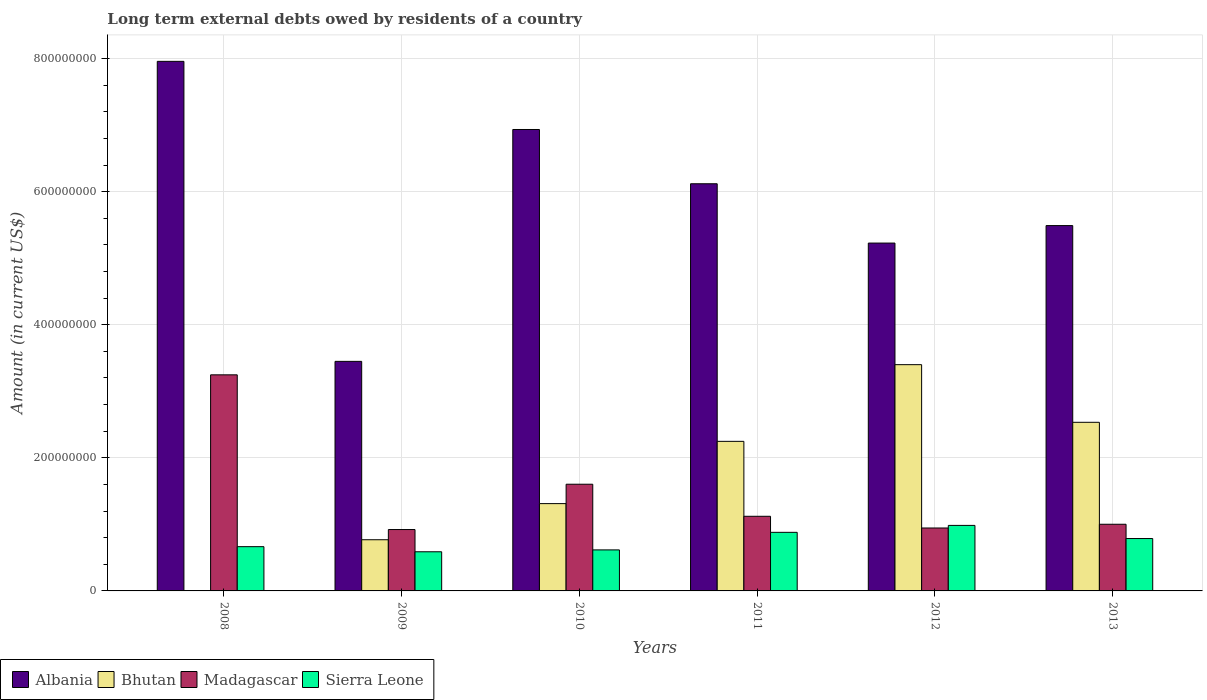How many groups of bars are there?
Keep it short and to the point. 6. Are the number of bars on each tick of the X-axis equal?
Make the answer very short. No. What is the label of the 5th group of bars from the left?
Provide a short and direct response. 2012. In how many cases, is the number of bars for a given year not equal to the number of legend labels?
Your answer should be compact. 1. What is the amount of long-term external debts owed by residents in Madagascar in 2008?
Ensure brevity in your answer.  3.25e+08. Across all years, what is the maximum amount of long-term external debts owed by residents in Albania?
Your answer should be compact. 7.96e+08. Across all years, what is the minimum amount of long-term external debts owed by residents in Bhutan?
Offer a very short reply. 0. In which year was the amount of long-term external debts owed by residents in Albania maximum?
Provide a succinct answer. 2008. What is the total amount of long-term external debts owed by residents in Albania in the graph?
Provide a succinct answer. 3.52e+09. What is the difference between the amount of long-term external debts owed by residents in Albania in 2012 and that in 2013?
Keep it short and to the point. -2.63e+07. What is the difference between the amount of long-term external debts owed by residents in Madagascar in 2011 and the amount of long-term external debts owed by residents in Bhutan in 2012?
Provide a succinct answer. -2.28e+08. What is the average amount of long-term external debts owed by residents in Albania per year?
Make the answer very short. 5.86e+08. In the year 2010, what is the difference between the amount of long-term external debts owed by residents in Albania and amount of long-term external debts owed by residents in Madagascar?
Offer a very short reply. 5.33e+08. What is the ratio of the amount of long-term external debts owed by residents in Madagascar in 2008 to that in 2010?
Your answer should be very brief. 2.03. Is the difference between the amount of long-term external debts owed by residents in Albania in 2008 and 2011 greater than the difference between the amount of long-term external debts owed by residents in Madagascar in 2008 and 2011?
Provide a short and direct response. No. What is the difference between the highest and the second highest amount of long-term external debts owed by residents in Sierra Leone?
Keep it short and to the point. 1.04e+07. What is the difference between the highest and the lowest amount of long-term external debts owed by residents in Madagascar?
Provide a succinct answer. 2.33e+08. In how many years, is the amount of long-term external debts owed by residents in Madagascar greater than the average amount of long-term external debts owed by residents in Madagascar taken over all years?
Provide a succinct answer. 2. How many bars are there?
Make the answer very short. 23. Are all the bars in the graph horizontal?
Provide a short and direct response. No. Are the values on the major ticks of Y-axis written in scientific E-notation?
Your response must be concise. No. Where does the legend appear in the graph?
Provide a succinct answer. Bottom left. How are the legend labels stacked?
Your answer should be very brief. Horizontal. What is the title of the graph?
Ensure brevity in your answer.  Long term external debts owed by residents of a country. What is the label or title of the X-axis?
Provide a succinct answer. Years. What is the Amount (in current US$) in Albania in 2008?
Ensure brevity in your answer.  7.96e+08. What is the Amount (in current US$) in Madagascar in 2008?
Your answer should be very brief. 3.25e+08. What is the Amount (in current US$) in Sierra Leone in 2008?
Keep it short and to the point. 6.65e+07. What is the Amount (in current US$) in Albania in 2009?
Provide a succinct answer. 3.45e+08. What is the Amount (in current US$) in Bhutan in 2009?
Keep it short and to the point. 7.69e+07. What is the Amount (in current US$) in Madagascar in 2009?
Make the answer very short. 9.23e+07. What is the Amount (in current US$) of Sierra Leone in 2009?
Your answer should be very brief. 5.88e+07. What is the Amount (in current US$) in Albania in 2010?
Keep it short and to the point. 6.93e+08. What is the Amount (in current US$) of Bhutan in 2010?
Your answer should be compact. 1.31e+08. What is the Amount (in current US$) in Madagascar in 2010?
Your answer should be compact. 1.60e+08. What is the Amount (in current US$) in Sierra Leone in 2010?
Your response must be concise. 6.16e+07. What is the Amount (in current US$) in Albania in 2011?
Keep it short and to the point. 6.12e+08. What is the Amount (in current US$) of Bhutan in 2011?
Your answer should be compact. 2.25e+08. What is the Amount (in current US$) of Madagascar in 2011?
Provide a short and direct response. 1.12e+08. What is the Amount (in current US$) of Sierra Leone in 2011?
Your answer should be very brief. 8.81e+07. What is the Amount (in current US$) of Albania in 2012?
Offer a terse response. 5.23e+08. What is the Amount (in current US$) in Bhutan in 2012?
Offer a very short reply. 3.40e+08. What is the Amount (in current US$) in Madagascar in 2012?
Your answer should be very brief. 9.46e+07. What is the Amount (in current US$) of Sierra Leone in 2012?
Your answer should be very brief. 9.85e+07. What is the Amount (in current US$) in Albania in 2013?
Give a very brief answer. 5.49e+08. What is the Amount (in current US$) in Bhutan in 2013?
Your answer should be very brief. 2.53e+08. What is the Amount (in current US$) of Madagascar in 2013?
Give a very brief answer. 1.00e+08. What is the Amount (in current US$) of Sierra Leone in 2013?
Make the answer very short. 7.87e+07. Across all years, what is the maximum Amount (in current US$) of Albania?
Ensure brevity in your answer.  7.96e+08. Across all years, what is the maximum Amount (in current US$) in Bhutan?
Offer a very short reply. 3.40e+08. Across all years, what is the maximum Amount (in current US$) in Madagascar?
Provide a succinct answer. 3.25e+08. Across all years, what is the maximum Amount (in current US$) in Sierra Leone?
Your answer should be very brief. 9.85e+07. Across all years, what is the minimum Amount (in current US$) in Albania?
Your answer should be very brief. 3.45e+08. Across all years, what is the minimum Amount (in current US$) in Bhutan?
Your response must be concise. 0. Across all years, what is the minimum Amount (in current US$) in Madagascar?
Provide a short and direct response. 9.23e+07. Across all years, what is the minimum Amount (in current US$) in Sierra Leone?
Offer a very short reply. 5.88e+07. What is the total Amount (in current US$) of Albania in the graph?
Give a very brief answer. 3.52e+09. What is the total Amount (in current US$) in Bhutan in the graph?
Your answer should be very brief. 1.03e+09. What is the total Amount (in current US$) in Madagascar in the graph?
Offer a very short reply. 8.84e+08. What is the total Amount (in current US$) in Sierra Leone in the graph?
Your answer should be compact. 4.52e+08. What is the difference between the Amount (in current US$) of Albania in 2008 and that in 2009?
Your answer should be compact. 4.51e+08. What is the difference between the Amount (in current US$) of Madagascar in 2008 and that in 2009?
Ensure brevity in your answer.  2.33e+08. What is the difference between the Amount (in current US$) in Sierra Leone in 2008 and that in 2009?
Provide a short and direct response. 7.70e+06. What is the difference between the Amount (in current US$) in Albania in 2008 and that in 2010?
Ensure brevity in your answer.  1.02e+08. What is the difference between the Amount (in current US$) of Madagascar in 2008 and that in 2010?
Offer a terse response. 1.64e+08. What is the difference between the Amount (in current US$) in Sierra Leone in 2008 and that in 2010?
Offer a terse response. 4.88e+06. What is the difference between the Amount (in current US$) in Albania in 2008 and that in 2011?
Ensure brevity in your answer.  1.84e+08. What is the difference between the Amount (in current US$) in Madagascar in 2008 and that in 2011?
Give a very brief answer. 2.13e+08. What is the difference between the Amount (in current US$) in Sierra Leone in 2008 and that in 2011?
Ensure brevity in your answer.  -2.15e+07. What is the difference between the Amount (in current US$) of Albania in 2008 and that in 2012?
Provide a short and direct response. 2.73e+08. What is the difference between the Amount (in current US$) in Madagascar in 2008 and that in 2012?
Your answer should be very brief. 2.30e+08. What is the difference between the Amount (in current US$) in Sierra Leone in 2008 and that in 2012?
Provide a short and direct response. -3.20e+07. What is the difference between the Amount (in current US$) of Albania in 2008 and that in 2013?
Offer a terse response. 2.47e+08. What is the difference between the Amount (in current US$) in Madagascar in 2008 and that in 2013?
Give a very brief answer. 2.25e+08. What is the difference between the Amount (in current US$) of Sierra Leone in 2008 and that in 2013?
Your response must be concise. -1.22e+07. What is the difference between the Amount (in current US$) in Albania in 2009 and that in 2010?
Offer a terse response. -3.48e+08. What is the difference between the Amount (in current US$) of Bhutan in 2009 and that in 2010?
Give a very brief answer. -5.43e+07. What is the difference between the Amount (in current US$) of Madagascar in 2009 and that in 2010?
Offer a very short reply. -6.81e+07. What is the difference between the Amount (in current US$) of Sierra Leone in 2009 and that in 2010?
Give a very brief answer. -2.82e+06. What is the difference between the Amount (in current US$) of Albania in 2009 and that in 2011?
Provide a short and direct response. -2.67e+08. What is the difference between the Amount (in current US$) of Bhutan in 2009 and that in 2011?
Provide a short and direct response. -1.48e+08. What is the difference between the Amount (in current US$) of Madagascar in 2009 and that in 2011?
Offer a very short reply. -1.99e+07. What is the difference between the Amount (in current US$) in Sierra Leone in 2009 and that in 2011?
Your answer should be very brief. -2.92e+07. What is the difference between the Amount (in current US$) of Albania in 2009 and that in 2012?
Provide a short and direct response. -1.78e+08. What is the difference between the Amount (in current US$) in Bhutan in 2009 and that in 2012?
Your answer should be compact. -2.63e+08. What is the difference between the Amount (in current US$) of Madagascar in 2009 and that in 2012?
Your response must be concise. -2.33e+06. What is the difference between the Amount (in current US$) of Sierra Leone in 2009 and that in 2012?
Your answer should be compact. -3.97e+07. What is the difference between the Amount (in current US$) in Albania in 2009 and that in 2013?
Your answer should be very brief. -2.04e+08. What is the difference between the Amount (in current US$) of Bhutan in 2009 and that in 2013?
Your response must be concise. -1.76e+08. What is the difference between the Amount (in current US$) of Madagascar in 2009 and that in 2013?
Keep it short and to the point. -7.94e+06. What is the difference between the Amount (in current US$) in Sierra Leone in 2009 and that in 2013?
Your response must be concise. -1.99e+07. What is the difference between the Amount (in current US$) in Albania in 2010 and that in 2011?
Provide a short and direct response. 8.15e+07. What is the difference between the Amount (in current US$) of Bhutan in 2010 and that in 2011?
Offer a very short reply. -9.36e+07. What is the difference between the Amount (in current US$) in Madagascar in 2010 and that in 2011?
Provide a short and direct response. 4.82e+07. What is the difference between the Amount (in current US$) of Sierra Leone in 2010 and that in 2011?
Keep it short and to the point. -2.64e+07. What is the difference between the Amount (in current US$) in Albania in 2010 and that in 2012?
Give a very brief answer. 1.71e+08. What is the difference between the Amount (in current US$) of Bhutan in 2010 and that in 2012?
Make the answer very short. -2.09e+08. What is the difference between the Amount (in current US$) of Madagascar in 2010 and that in 2012?
Your response must be concise. 6.58e+07. What is the difference between the Amount (in current US$) of Sierra Leone in 2010 and that in 2012?
Your response must be concise. -3.68e+07. What is the difference between the Amount (in current US$) in Albania in 2010 and that in 2013?
Keep it short and to the point. 1.44e+08. What is the difference between the Amount (in current US$) of Bhutan in 2010 and that in 2013?
Your answer should be compact. -1.22e+08. What is the difference between the Amount (in current US$) in Madagascar in 2010 and that in 2013?
Provide a short and direct response. 6.02e+07. What is the difference between the Amount (in current US$) of Sierra Leone in 2010 and that in 2013?
Your answer should be compact. -1.71e+07. What is the difference between the Amount (in current US$) in Albania in 2011 and that in 2012?
Provide a short and direct response. 8.91e+07. What is the difference between the Amount (in current US$) in Bhutan in 2011 and that in 2012?
Provide a succinct answer. -1.15e+08. What is the difference between the Amount (in current US$) of Madagascar in 2011 and that in 2012?
Ensure brevity in your answer.  1.76e+07. What is the difference between the Amount (in current US$) of Sierra Leone in 2011 and that in 2012?
Your answer should be very brief. -1.04e+07. What is the difference between the Amount (in current US$) in Albania in 2011 and that in 2013?
Offer a very short reply. 6.29e+07. What is the difference between the Amount (in current US$) of Bhutan in 2011 and that in 2013?
Offer a very short reply. -2.86e+07. What is the difference between the Amount (in current US$) of Madagascar in 2011 and that in 2013?
Keep it short and to the point. 1.20e+07. What is the difference between the Amount (in current US$) in Sierra Leone in 2011 and that in 2013?
Your answer should be very brief. 9.32e+06. What is the difference between the Amount (in current US$) in Albania in 2012 and that in 2013?
Provide a short and direct response. -2.63e+07. What is the difference between the Amount (in current US$) in Bhutan in 2012 and that in 2013?
Ensure brevity in your answer.  8.66e+07. What is the difference between the Amount (in current US$) in Madagascar in 2012 and that in 2013?
Make the answer very short. -5.60e+06. What is the difference between the Amount (in current US$) in Sierra Leone in 2012 and that in 2013?
Your answer should be very brief. 1.98e+07. What is the difference between the Amount (in current US$) in Albania in 2008 and the Amount (in current US$) in Bhutan in 2009?
Your answer should be compact. 7.19e+08. What is the difference between the Amount (in current US$) in Albania in 2008 and the Amount (in current US$) in Madagascar in 2009?
Provide a succinct answer. 7.04e+08. What is the difference between the Amount (in current US$) in Albania in 2008 and the Amount (in current US$) in Sierra Leone in 2009?
Keep it short and to the point. 7.37e+08. What is the difference between the Amount (in current US$) in Madagascar in 2008 and the Amount (in current US$) in Sierra Leone in 2009?
Make the answer very short. 2.66e+08. What is the difference between the Amount (in current US$) in Albania in 2008 and the Amount (in current US$) in Bhutan in 2010?
Keep it short and to the point. 6.65e+08. What is the difference between the Amount (in current US$) of Albania in 2008 and the Amount (in current US$) of Madagascar in 2010?
Ensure brevity in your answer.  6.36e+08. What is the difference between the Amount (in current US$) of Albania in 2008 and the Amount (in current US$) of Sierra Leone in 2010?
Keep it short and to the point. 7.34e+08. What is the difference between the Amount (in current US$) in Madagascar in 2008 and the Amount (in current US$) in Sierra Leone in 2010?
Offer a terse response. 2.63e+08. What is the difference between the Amount (in current US$) in Albania in 2008 and the Amount (in current US$) in Bhutan in 2011?
Your response must be concise. 5.71e+08. What is the difference between the Amount (in current US$) of Albania in 2008 and the Amount (in current US$) of Madagascar in 2011?
Offer a very short reply. 6.84e+08. What is the difference between the Amount (in current US$) in Albania in 2008 and the Amount (in current US$) in Sierra Leone in 2011?
Offer a very short reply. 7.08e+08. What is the difference between the Amount (in current US$) of Madagascar in 2008 and the Amount (in current US$) of Sierra Leone in 2011?
Ensure brevity in your answer.  2.37e+08. What is the difference between the Amount (in current US$) of Albania in 2008 and the Amount (in current US$) of Bhutan in 2012?
Provide a short and direct response. 4.56e+08. What is the difference between the Amount (in current US$) in Albania in 2008 and the Amount (in current US$) in Madagascar in 2012?
Give a very brief answer. 7.01e+08. What is the difference between the Amount (in current US$) in Albania in 2008 and the Amount (in current US$) in Sierra Leone in 2012?
Offer a terse response. 6.97e+08. What is the difference between the Amount (in current US$) of Madagascar in 2008 and the Amount (in current US$) of Sierra Leone in 2012?
Keep it short and to the point. 2.26e+08. What is the difference between the Amount (in current US$) in Albania in 2008 and the Amount (in current US$) in Bhutan in 2013?
Provide a succinct answer. 5.42e+08. What is the difference between the Amount (in current US$) of Albania in 2008 and the Amount (in current US$) of Madagascar in 2013?
Keep it short and to the point. 6.96e+08. What is the difference between the Amount (in current US$) in Albania in 2008 and the Amount (in current US$) in Sierra Leone in 2013?
Offer a very short reply. 7.17e+08. What is the difference between the Amount (in current US$) of Madagascar in 2008 and the Amount (in current US$) of Sierra Leone in 2013?
Provide a short and direct response. 2.46e+08. What is the difference between the Amount (in current US$) in Albania in 2009 and the Amount (in current US$) in Bhutan in 2010?
Offer a terse response. 2.14e+08. What is the difference between the Amount (in current US$) in Albania in 2009 and the Amount (in current US$) in Madagascar in 2010?
Offer a very short reply. 1.85e+08. What is the difference between the Amount (in current US$) of Albania in 2009 and the Amount (in current US$) of Sierra Leone in 2010?
Make the answer very short. 2.83e+08. What is the difference between the Amount (in current US$) of Bhutan in 2009 and the Amount (in current US$) of Madagascar in 2010?
Your response must be concise. -8.34e+07. What is the difference between the Amount (in current US$) of Bhutan in 2009 and the Amount (in current US$) of Sierra Leone in 2010?
Make the answer very short. 1.53e+07. What is the difference between the Amount (in current US$) of Madagascar in 2009 and the Amount (in current US$) of Sierra Leone in 2010?
Provide a succinct answer. 3.06e+07. What is the difference between the Amount (in current US$) in Albania in 2009 and the Amount (in current US$) in Bhutan in 2011?
Make the answer very short. 1.20e+08. What is the difference between the Amount (in current US$) of Albania in 2009 and the Amount (in current US$) of Madagascar in 2011?
Make the answer very short. 2.33e+08. What is the difference between the Amount (in current US$) of Albania in 2009 and the Amount (in current US$) of Sierra Leone in 2011?
Offer a very short reply. 2.57e+08. What is the difference between the Amount (in current US$) of Bhutan in 2009 and the Amount (in current US$) of Madagascar in 2011?
Ensure brevity in your answer.  -3.52e+07. What is the difference between the Amount (in current US$) in Bhutan in 2009 and the Amount (in current US$) in Sierra Leone in 2011?
Offer a terse response. -1.11e+07. What is the difference between the Amount (in current US$) in Madagascar in 2009 and the Amount (in current US$) in Sierra Leone in 2011?
Keep it short and to the point. 4.20e+06. What is the difference between the Amount (in current US$) in Albania in 2009 and the Amount (in current US$) in Bhutan in 2012?
Provide a short and direct response. 4.95e+06. What is the difference between the Amount (in current US$) of Albania in 2009 and the Amount (in current US$) of Madagascar in 2012?
Your answer should be compact. 2.50e+08. What is the difference between the Amount (in current US$) of Albania in 2009 and the Amount (in current US$) of Sierra Leone in 2012?
Ensure brevity in your answer.  2.46e+08. What is the difference between the Amount (in current US$) in Bhutan in 2009 and the Amount (in current US$) in Madagascar in 2012?
Provide a short and direct response. -1.77e+07. What is the difference between the Amount (in current US$) in Bhutan in 2009 and the Amount (in current US$) in Sierra Leone in 2012?
Give a very brief answer. -2.16e+07. What is the difference between the Amount (in current US$) of Madagascar in 2009 and the Amount (in current US$) of Sierra Leone in 2012?
Your answer should be very brief. -6.23e+06. What is the difference between the Amount (in current US$) of Albania in 2009 and the Amount (in current US$) of Bhutan in 2013?
Offer a very short reply. 9.16e+07. What is the difference between the Amount (in current US$) of Albania in 2009 and the Amount (in current US$) of Madagascar in 2013?
Provide a succinct answer. 2.45e+08. What is the difference between the Amount (in current US$) of Albania in 2009 and the Amount (in current US$) of Sierra Leone in 2013?
Provide a short and direct response. 2.66e+08. What is the difference between the Amount (in current US$) of Bhutan in 2009 and the Amount (in current US$) of Madagascar in 2013?
Your response must be concise. -2.33e+07. What is the difference between the Amount (in current US$) of Bhutan in 2009 and the Amount (in current US$) of Sierra Leone in 2013?
Ensure brevity in your answer.  -1.80e+06. What is the difference between the Amount (in current US$) in Madagascar in 2009 and the Amount (in current US$) in Sierra Leone in 2013?
Offer a terse response. 1.35e+07. What is the difference between the Amount (in current US$) of Albania in 2010 and the Amount (in current US$) of Bhutan in 2011?
Your response must be concise. 4.69e+08. What is the difference between the Amount (in current US$) in Albania in 2010 and the Amount (in current US$) in Madagascar in 2011?
Make the answer very short. 5.81e+08. What is the difference between the Amount (in current US$) in Albania in 2010 and the Amount (in current US$) in Sierra Leone in 2011?
Provide a succinct answer. 6.05e+08. What is the difference between the Amount (in current US$) in Bhutan in 2010 and the Amount (in current US$) in Madagascar in 2011?
Ensure brevity in your answer.  1.90e+07. What is the difference between the Amount (in current US$) of Bhutan in 2010 and the Amount (in current US$) of Sierra Leone in 2011?
Offer a terse response. 4.32e+07. What is the difference between the Amount (in current US$) in Madagascar in 2010 and the Amount (in current US$) in Sierra Leone in 2011?
Provide a short and direct response. 7.23e+07. What is the difference between the Amount (in current US$) of Albania in 2010 and the Amount (in current US$) of Bhutan in 2012?
Your answer should be compact. 3.53e+08. What is the difference between the Amount (in current US$) of Albania in 2010 and the Amount (in current US$) of Madagascar in 2012?
Offer a terse response. 5.99e+08. What is the difference between the Amount (in current US$) in Albania in 2010 and the Amount (in current US$) in Sierra Leone in 2012?
Offer a terse response. 5.95e+08. What is the difference between the Amount (in current US$) of Bhutan in 2010 and the Amount (in current US$) of Madagascar in 2012?
Your response must be concise. 3.66e+07. What is the difference between the Amount (in current US$) of Bhutan in 2010 and the Amount (in current US$) of Sierra Leone in 2012?
Provide a short and direct response. 3.27e+07. What is the difference between the Amount (in current US$) in Madagascar in 2010 and the Amount (in current US$) in Sierra Leone in 2012?
Your answer should be compact. 6.19e+07. What is the difference between the Amount (in current US$) in Albania in 2010 and the Amount (in current US$) in Bhutan in 2013?
Ensure brevity in your answer.  4.40e+08. What is the difference between the Amount (in current US$) in Albania in 2010 and the Amount (in current US$) in Madagascar in 2013?
Keep it short and to the point. 5.93e+08. What is the difference between the Amount (in current US$) of Albania in 2010 and the Amount (in current US$) of Sierra Leone in 2013?
Give a very brief answer. 6.15e+08. What is the difference between the Amount (in current US$) of Bhutan in 2010 and the Amount (in current US$) of Madagascar in 2013?
Offer a terse response. 3.10e+07. What is the difference between the Amount (in current US$) of Bhutan in 2010 and the Amount (in current US$) of Sierra Leone in 2013?
Offer a very short reply. 5.25e+07. What is the difference between the Amount (in current US$) in Madagascar in 2010 and the Amount (in current US$) in Sierra Leone in 2013?
Give a very brief answer. 8.16e+07. What is the difference between the Amount (in current US$) of Albania in 2011 and the Amount (in current US$) of Bhutan in 2012?
Provide a succinct answer. 2.72e+08. What is the difference between the Amount (in current US$) in Albania in 2011 and the Amount (in current US$) in Madagascar in 2012?
Make the answer very short. 5.17e+08. What is the difference between the Amount (in current US$) in Albania in 2011 and the Amount (in current US$) in Sierra Leone in 2012?
Your answer should be compact. 5.13e+08. What is the difference between the Amount (in current US$) of Bhutan in 2011 and the Amount (in current US$) of Madagascar in 2012?
Provide a short and direct response. 1.30e+08. What is the difference between the Amount (in current US$) in Bhutan in 2011 and the Amount (in current US$) in Sierra Leone in 2012?
Ensure brevity in your answer.  1.26e+08. What is the difference between the Amount (in current US$) of Madagascar in 2011 and the Amount (in current US$) of Sierra Leone in 2012?
Offer a terse response. 1.37e+07. What is the difference between the Amount (in current US$) in Albania in 2011 and the Amount (in current US$) in Bhutan in 2013?
Provide a short and direct response. 3.59e+08. What is the difference between the Amount (in current US$) in Albania in 2011 and the Amount (in current US$) in Madagascar in 2013?
Make the answer very short. 5.12e+08. What is the difference between the Amount (in current US$) of Albania in 2011 and the Amount (in current US$) of Sierra Leone in 2013?
Offer a very short reply. 5.33e+08. What is the difference between the Amount (in current US$) in Bhutan in 2011 and the Amount (in current US$) in Madagascar in 2013?
Provide a succinct answer. 1.25e+08. What is the difference between the Amount (in current US$) in Bhutan in 2011 and the Amount (in current US$) in Sierra Leone in 2013?
Keep it short and to the point. 1.46e+08. What is the difference between the Amount (in current US$) in Madagascar in 2011 and the Amount (in current US$) in Sierra Leone in 2013?
Give a very brief answer. 3.34e+07. What is the difference between the Amount (in current US$) in Albania in 2012 and the Amount (in current US$) in Bhutan in 2013?
Keep it short and to the point. 2.69e+08. What is the difference between the Amount (in current US$) of Albania in 2012 and the Amount (in current US$) of Madagascar in 2013?
Keep it short and to the point. 4.23e+08. What is the difference between the Amount (in current US$) in Albania in 2012 and the Amount (in current US$) in Sierra Leone in 2013?
Keep it short and to the point. 4.44e+08. What is the difference between the Amount (in current US$) of Bhutan in 2012 and the Amount (in current US$) of Madagascar in 2013?
Keep it short and to the point. 2.40e+08. What is the difference between the Amount (in current US$) of Bhutan in 2012 and the Amount (in current US$) of Sierra Leone in 2013?
Keep it short and to the point. 2.61e+08. What is the difference between the Amount (in current US$) of Madagascar in 2012 and the Amount (in current US$) of Sierra Leone in 2013?
Offer a terse response. 1.59e+07. What is the average Amount (in current US$) of Albania per year?
Make the answer very short. 5.86e+08. What is the average Amount (in current US$) in Bhutan per year?
Your answer should be compact. 1.71e+08. What is the average Amount (in current US$) of Madagascar per year?
Provide a short and direct response. 1.47e+08. What is the average Amount (in current US$) of Sierra Leone per year?
Make the answer very short. 7.54e+07. In the year 2008, what is the difference between the Amount (in current US$) of Albania and Amount (in current US$) of Madagascar?
Give a very brief answer. 4.71e+08. In the year 2008, what is the difference between the Amount (in current US$) of Albania and Amount (in current US$) of Sierra Leone?
Your response must be concise. 7.29e+08. In the year 2008, what is the difference between the Amount (in current US$) of Madagascar and Amount (in current US$) of Sierra Leone?
Ensure brevity in your answer.  2.58e+08. In the year 2009, what is the difference between the Amount (in current US$) in Albania and Amount (in current US$) in Bhutan?
Make the answer very short. 2.68e+08. In the year 2009, what is the difference between the Amount (in current US$) in Albania and Amount (in current US$) in Madagascar?
Offer a very short reply. 2.53e+08. In the year 2009, what is the difference between the Amount (in current US$) of Albania and Amount (in current US$) of Sierra Leone?
Ensure brevity in your answer.  2.86e+08. In the year 2009, what is the difference between the Amount (in current US$) in Bhutan and Amount (in current US$) in Madagascar?
Provide a succinct answer. -1.53e+07. In the year 2009, what is the difference between the Amount (in current US$) of Bhutan and Amount (in current US$) of Sierra Leone?
Give a very brief answer. 1.81e+07. In the year 2009, what is the difference between the Amount (in current US$) of Madagascar and Amount (in current US$) of Sierra Leone?
Offer a very short reply. 3.34e+07. In the year 2010, what is the difference between the Amount (in current US$) of Albania and Amount (in current US$) of Bhutan?
Provide a short and direct response. 5.62e+08. In the year 2010, what is the difference between the Amount (in current US$) in Albania and Amount (in current US$) in Madagascar?
Your answer should be very brief. 5.33e+08. In the year 2010, what is the difference between the Amount (in current US$) in Albania and Amount (in current US$) in Sierra Leone?
Your response must be concise. 6.32e+08. In the year 2010, what is the difference between the Amount (in current US$) in Bhutan and Amount (in current US$) in Madagascar?
Provide a short and direct response. -2.91e+07. In the year 2010, what is the difference between the Amount (in current US$) of Bhutan and Amount (in current US$) of Sierra Leone?
Keep it short and to the point. 6.96e+07. In the year 2010, what is the difference between the Amount (in current US$) of Madagascar and Amount (in current US$) of Sierra Leone?
Your answer should be compact. 9.87e+07. In the year 2011, what is the difference between the Amount (in current US$) in Albania and Amount (in current US$) in Bhutan?
Offer a terse response. 3.87e+08. In the year 2011, what is the difference between the Amount (in current US$) in Albania and Amount (in current US$) in Madagascar?
Make the answer very short. 5.00e+08. In the year 2011, what is the difference between the Amount (in current US$) in Albania and Amount (in current US$) in Sierra Leone?
Make the answer very short. 5.24e+08. In the year 2011, what is the difference between the Amount (in current US$) of Bhutan and Amount (in current US$) of Madagascar?
Your answer should be very brief. 1.13e+08. In the year 2011, what is the difference between the Amount (in current US$) of Bhutan and Amount (in current US$) of Sierra Leone?
Offer a very short reply. 1.37e+08. In the year 2011, what is the difference between the Amount (in current US$) in Madagascar and Amount (in current US$) in Sierra Leone?
Offer a terse response. 2.41e+07. In the year 2012, what is the difference between the Amount (in current US$) of Albania and Amount (in current US$) of Bhutan?
Ensure brevity in your answer.  1.83e+08. In the year 2012, what is the difference between the Amount (in current US$) of Albania and Amount (in current US$) of Madagascar?
Provide a short and direct response. 4.28e+08. In the year 2012, what is the difference between the Amount (in current US$) in Albania and Amount (in current US$) in Sierra Leone?
Your answer should be compact. 4.24e+08. In the year 2012, what is the difference between the Amount (in current US$) of Bhutan and Amount (in current US$) of Madagascar?
Your response must be concise. 2.45e+08. In the year 2012, what is the difference between the Amount (in current US$) of Bhutan and Amount (in current US$) of Sierra Leone?
Your answer should be compact. 2.42e+08. In the year 2012, what is the difference between the Amount (in current US$) in Madagascar and Amount (in current US$) in Sierra Leone?
Make the answer very short. -3.90e+06. In the year 2013, what is the difference between the Amount (in current US$) of Albania and Amount (in current US$) of Bhutan?
Make the answer very short. 2.96e+08. In the year 2013, what is the difference between the Amount (in current US$) in Albania and Amount (in current US$) in Madagascar?
Your response must be concise. 4.49e+08. In the year 2013, what is the difference between the Amount (in current US$) in Albania and Amount (in current US$) in Sierra Leone?
Your answer should be very brief. 4.70e+08. In the year 2013, what is the difference between the Amount (in current US$) in Bhutan and Amount (in current US$) in Madagascar?
Your response must be concise. 1.53e+08. In the year 2013, what is the difference between the Amount (in current US$) in Bhutan and Amount (in current US$) in Sierra Leone?
Make the answer very short. 1.75e+08. In the year 2013, what is the difference between the Amount (in current US$) in Madagascar and Amount (in current US$) in Sierra Leone?
Your response must be concise. 2.15e+07. What is the ratio of the Amount (in current US$) of Albania in 2008 to that in 2009?
Provide a succinct answer. 2.31. What is the ratio of the Amount (in current US$) in Madagascar in 2008 to that in 2009?
Ensure brevity in your answer.  3.52. What is the ratio of the Amount (in current US$) in Sierra Leone in 2008 to that in 2009?
Your answer should be compact. 1.13. What is the ratio of the Amount (in current US$) in Albania in 2008 to that in 2010?
Ensure brevity in your answer.  1.15. What is the ratio of the Amount (in current US$) in Madagascar in 2008 to that in 2010?
Offer a terse response. 2.03. What is the ratio of the Amount (in current US$) in Sierra Leone in 2008 to that in 2010?
Ensure brevity in your answer.  1.08. What is the ratio of the Amount (in current US$) of Albania in 2008 to that in 2011?
Offer a very short reply. 1.3. What is the ratio of the Amount (in current US$) of Madagascar in 2008 to that in 2011?
Your answer should be very brief. 2.9. What is the ratio of the Amount (in current US$) of Sierra Leone in 2008 to that in 2011?
Make the answer very short. 0.76. What is the ratio of the Amount (in current US$) in Albania in 2008 to that in 2012?
Your response must be concise. 1.52. What is the ratio of the Amount (in current US$) in Madagascar in 2008 to that in 2012?
Your response must be concise. 3.43. What is the ratio of the Amount (in current US$) in Sierra Leone in 2008 to that in 2012?
Offer a terse response. 0.68. What is the ratio of the Amount (in current US$) in Albania in 2008 to that in 2013?
Offer a very short reply. 1.45. What is the ratio of the Amount (in current US$) of Madagascar in 2008 to that in 2013?
Ensure brevity in your answer.  3.24. What is the ratio of the Amount (in current US$) in Sierra Leone in 2008 to that in 2013?
Make the answer very short. 0.84. What is the ratio of the Amount (in current US$) of Albania in 2009 to that in 2010?
Provide a short and direct response. 0.5. What is the ratio of the Amount (in current US$) of Bhutan in 2009 to that in 2010?
Provide a short and direct response. 0.59. What is the ratio of the Amount (in current US$) of Madagascar in 2009 to that in 2010?
Offer a very short reply. 0.58. What is the ratio of the Amount (in current US$) in Sierra Leone in 2009 to that in 2010?
Make the answer very short. 0.95. What is the ratio of the Amount (in current US$) in Albania in 2009 to that in 2011?
Provide a short and direct response. 0.56. What is the ratio of the Amount (in current US$) in Bhutan in 2009 to that in 2011?
Offer a terse response. 0.34. What is the ratio of the Amount (in current US$) in Madagascar in 2009 to that in 2011?
Your response must be concise. 0.82. What is the ratio of the Amount (in current US$) of Sierra Leone in 2009 to that in 2011?
Offer a terse response. 0.67. What is the ratio of the Amount (in current US$) in Albania in 2009 to that in 2012?
Give a very brief answer. 0.66. What is the ratio of the Amount (in current US$) in Bhutan in 2009 to that in 2012?
Give a very brief answer. 0.23. What is the ratio of the Amount (in current US$) of Madagascar in 2009 to that in 2012?
Your answer should be very brief. 0.98. What is the ratio of the Amount (in current US$) in Sierra Leone in 2009 to that in 2012?
Ensure brevity in your answer.  0.6. What is the ratio of the Amount (in current US$) in Albania in 2009 to that in 2013?
Your answer should be very brief. 0.63. What is the ratio of the Amount (in current US$) of Bhutan in 2009 to that in 2013?
Your response must be concise. 0.3. What is the ratio of the Amount (in current US$) in Madagascar in 2009 to that in 2013?
Make the answer very short. 0.92. What is the ratio of the Amount (in current US$) in Sierra Leone in 2009 to that in 2013?
Ensure brevity in your answer.  0.75. What is the ratio of the Amount (in current US$) in Albania in 2010 to that in 2011?
Your response must be concise. 1.13. What is the ratio of the Amount (in current US$) of Bhutan in 2010 to that in 2011?
Your answer should be very brief. 0.58. What is the ratio of the Amount (in current US$) in Madagascar in 2010 to that in 2011?
Your response must be concise. 1.43. What is the ratio of the Amount (in current US$) of Sierra Leone in 2010 to that in 2011?
Your answer should be compact. 0.7. What is the ratio of the Amount (in current US$) of Albania in 2010 to that in 2012?
Your response must be concise. 1.33. What is the ratio of the Amount (in current US$) in Bhutan in 2010 to that in 2012?
Provide a short and direct response. 0.39. What is the ratio of the Amount (in current US$) in Madagascar in 2010 to that in 2012?
Your answer should be very brief. 1.7. What is the ratio of the Amount (in current US$) in Sierra Leone in 2010 to that in 2012?
Provide a short and direct response. 0.63. What is the ratio of the Amount (in current US$) in Albania in 2010 to that in 2013?
Provide a succinct answer. 1.26. What is the ratio of the Amount (in current US$) of Bhutan in 2010 to that in 2013?
Your answer should be compact. 0.52. What is the ratio of the Amount (in current US$) of Madagascar in 2010 to that in 2013?
Give a very brief answer. 1.6. What is the ratio of the Amount (in current US$) of Sierra Leone in 2010 to that in 2013?
Offer a terse response. 0.78. What is the ratio of the Amount (in current US$) of Albania in 2011 to that in 2012?
Your response must be concise. 1.17. What is the ratio of the Amount (in current US$) in Bhutan in 2011 to that in 2012?
Give a very brief answer. 0.66. What is the ratio of the Amount (in current US$) in Madagascar in 2011 to that in 2012?
Offer a very short reply. 1.19. What is the ratio of the Amount (in current US$) in Sierra Leone in 2011 to that in 2012?
Your answer should be very brief. 0.89. What is the ratio of the Amount (in current US$) of Albania in 2011 to that in 2013?
Provide a short and direct response. 1.11. What is the ratio of the Amount (in current US$) in Bhutan in 2011 to that in 2013?
Give a very brief answer. 0.89. What is the ratio of the Amount (in current US$) of Madagascar in 2011 to that in 2013?
Give a very brief answer. 1.12. What is the ratio of the Amount (in current US$) in Sierra Leone in 2011 to that in 2013?
Your answer should be compact. 1.12. What is the ratio of the Amount (in current US$) of Albania in 2012 to that in 2013?
Provide a short and direct response. 0.95. What is the ratio of the Amount (in current US$) of Bhutan in 2012 to that in 2013?
Make the answer very short. 1.34. What is the ratio of the Amount (in current US$) of Madagascar in 2012 to that in 2013?
Your answer should be compact. 0.94. What is the ratio of the Amount (in current US$) in Sierra Leone in 2012 to that in 2013?
Offer a very short reply. 1.25. What is the difference between the highest and the second highest Amount (in current US$) in Albania?
Offer a very short reply. 1.02e+08. What is the difference between the highest and the second highest Amount (in current US$) in Bhutan?
Your answer should be very brief. 8.66e+07. What is the difference between the highest and the second highest Amount (in current US$) of Madagascar?
Your response must be concise. 1.64e+08. What is the difference between the highest and the second highest Amount (in current US$) of Sierra Leone?
Ensure brevity in your answer.  1.04e+07. What is the difference between the highest and the lowest Amount (in current US$) of Albania?
Offer a terse response. 4.51e+08. What is the difference between the highest and the lowest Amount (in current US$) of Bhutan?
Your answer should be very brief. 3.40e+08. What is the difference between the highest and the lowest Amount (in current US$) in Madagascar?
Provide a succinct answer. 2.33e+08. What is the difference between the highest and the lowest Amount (in current US$) in Sierra Leone?
Provide a short and direct response. 3.97e+07. 